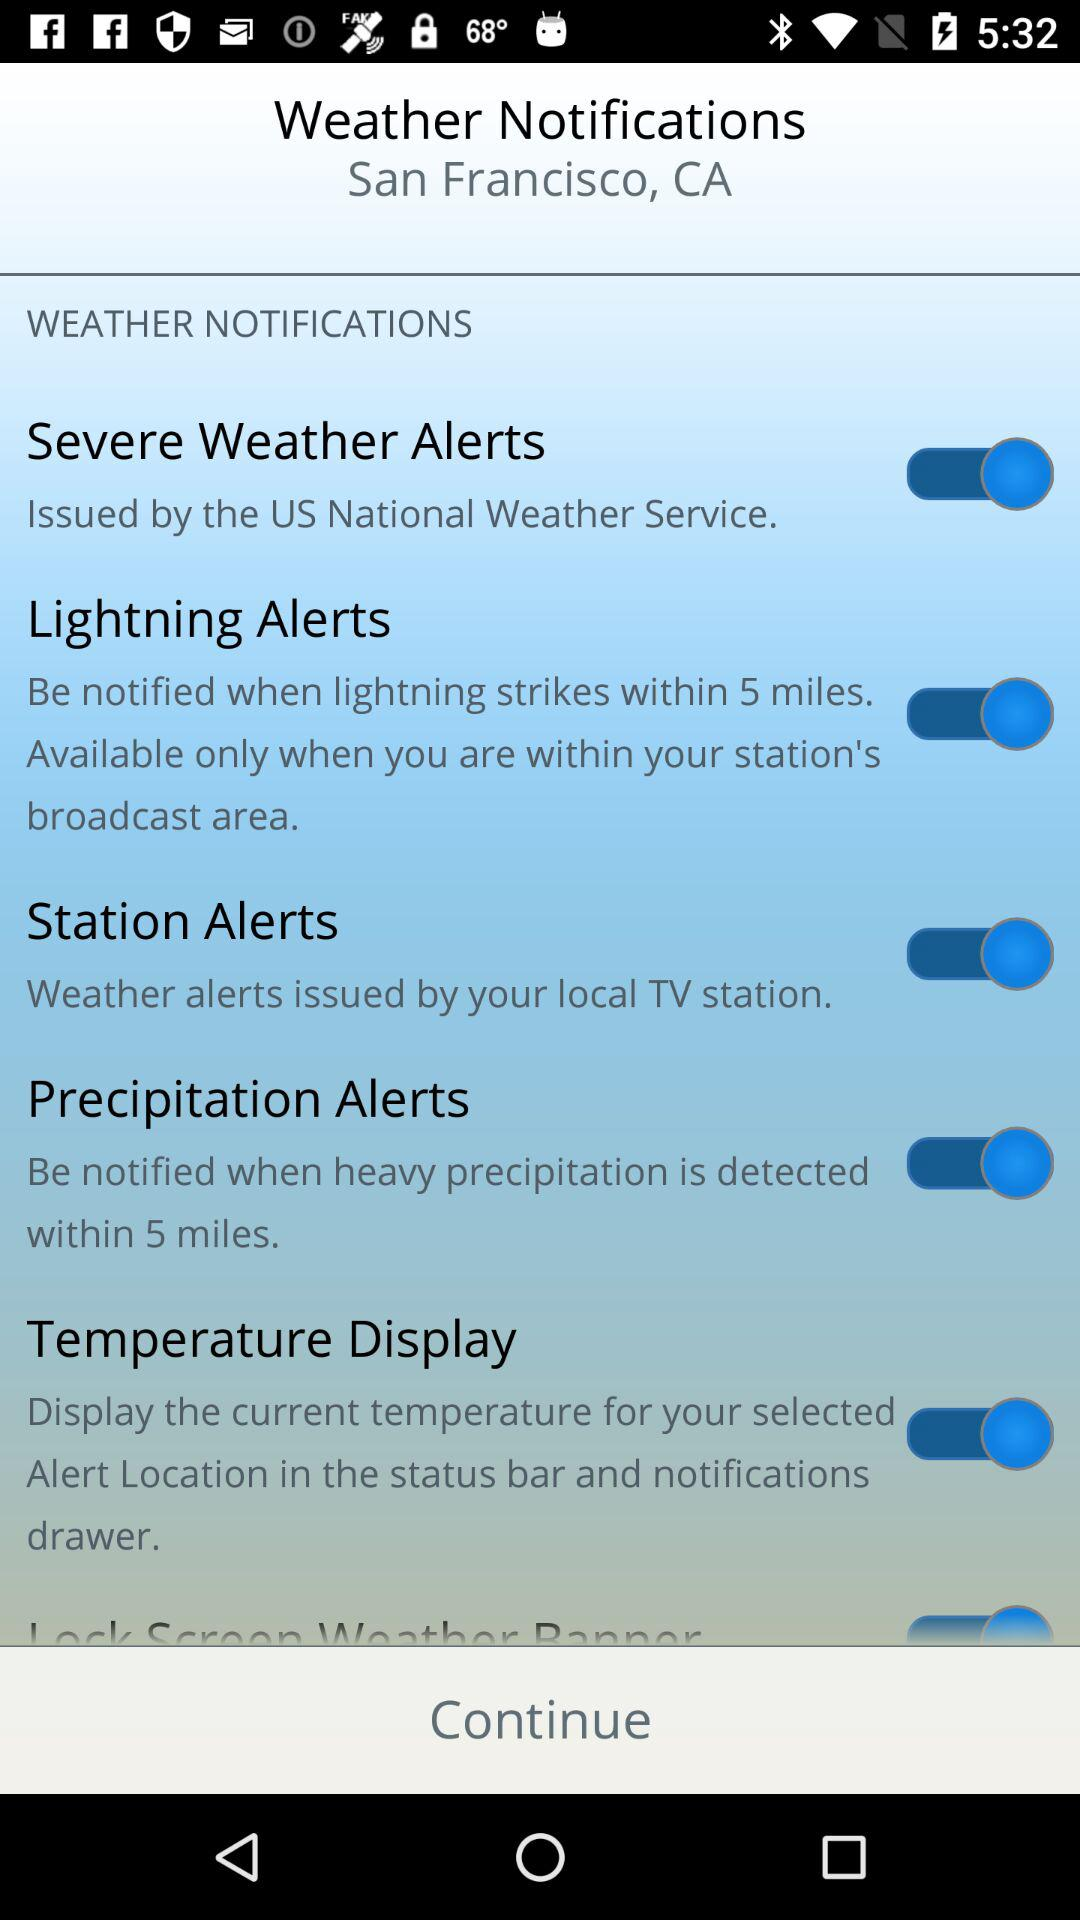What is the status of "Temperature Display"? The status is "on". 